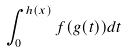Convert formula to latex. <formula><loc_0><loc_0><loc_500><loc_500>\int _ { 0 } ^ { h ( x ) } f ( g ( t ) ) d t</formula> 